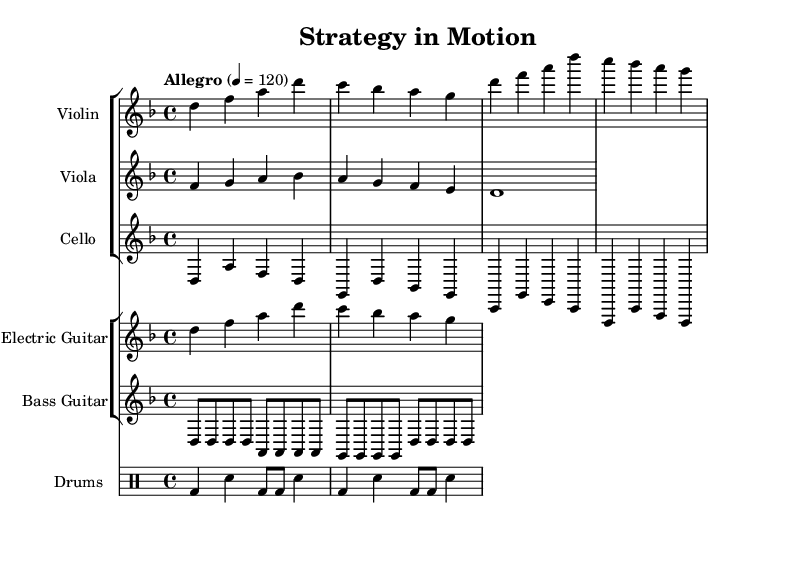What is the key signature of this music? The key signature is D minor, which has one flat (B flat). This can be identified by looking at the key signature at the beginning of the staff.
Answer: D minor What is the time signature of this music? The time signature is 4/4, indicated at the beginning of the score. This means there are four beats per measure and the quarter note receives one beat.
Answer: 4/4 What is the tempo marking for this piece? The tempo marking is "Allegro," which indicates a fast tempo. The number 120 signifies the beats per minute. This information is located at the start of the score.
Answer: Allegro, 120 Which instruments are featured in the score? The instruments featured are Violin, Viola, Cello, Electric Guitar, Bass Guitar, and Drums. Each instrument is indicated at the top of its respective staff.
Answer: Violin, Viola, Cello, Electric Guitar, Bass Guitar, Drums What rhythmic pattern does the bass guitar primarily use? The bass guitar primarily uses a basic eighth note pattern, characterized by alternating notes. This is evident in the notation which shows eight notes per measure grouped systematically.
Answer: Eighth note pattern How many measures are in the violin part provided? The violin part contains a total of 4 measures. By counting the individual bar lines in the violin staff, we can determine the number of measures present.
Answer: 4 measures How does the cello's harmony relate to the overall fusion theme? The cello provides a basic harmony outline that complements the melodic lines of the strings and reinforces the rock elements. Its straightforward progression establishes a foundation, blending classical with modern rock. This is derived from analyzing how the cello's notes interact with the upper strings and guitar parts.
Answer: Basic harmony outline 